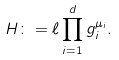Convert formula to latex. <formula><loc_0><loc_0><loc_500><loc_500>H \colon = \ell \prod _ { i = 1 } ^ { d } g _ { i } ^ { \mu _ { i } } .</formula> 